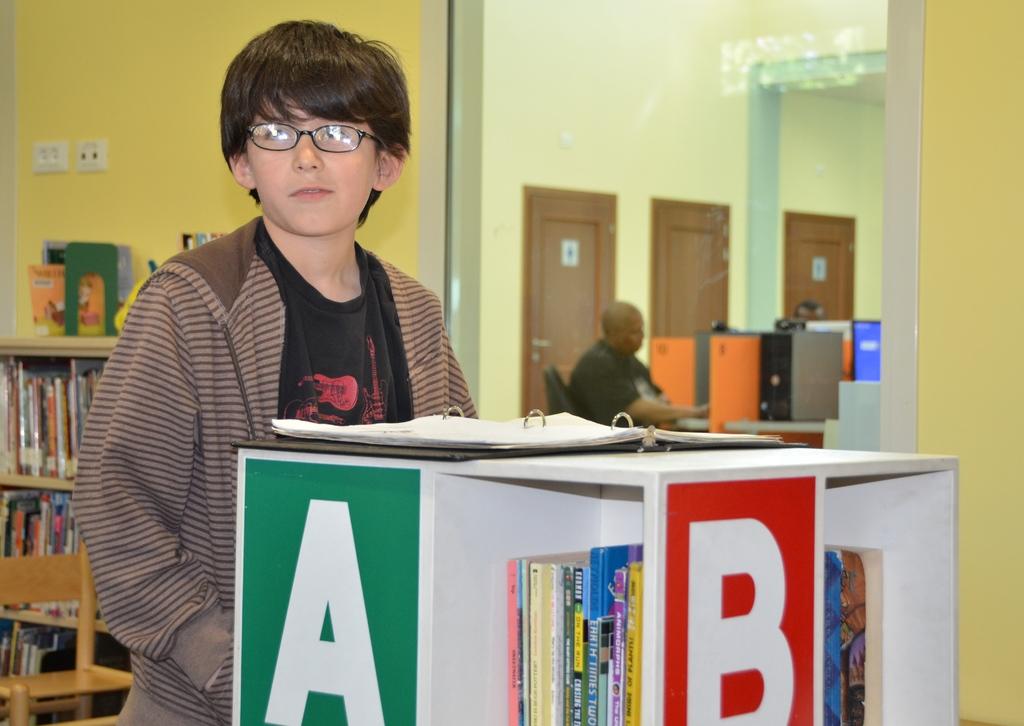What letter is in the green block?
Your answer should be compact. A. What is the letter in red?
Offer a very short reply. B. 